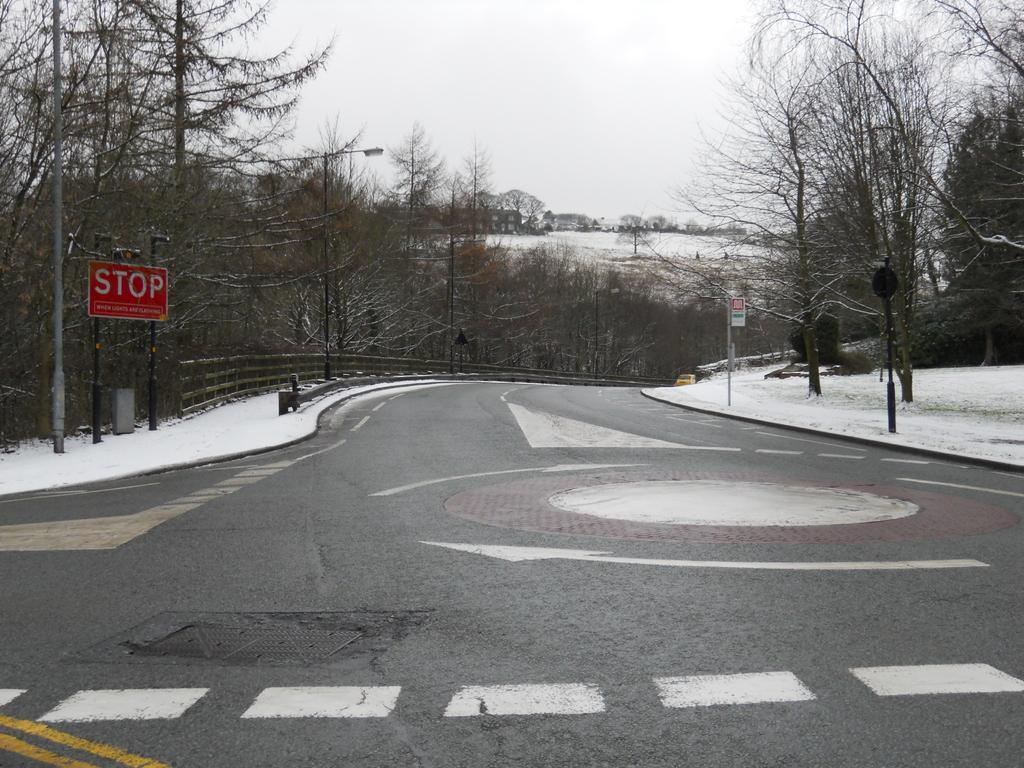Could you give a brief overview of what you see in this image? As we can see in the image there are trees. There is snow, sign pole, fence, street lamp and at the top there is sky. 